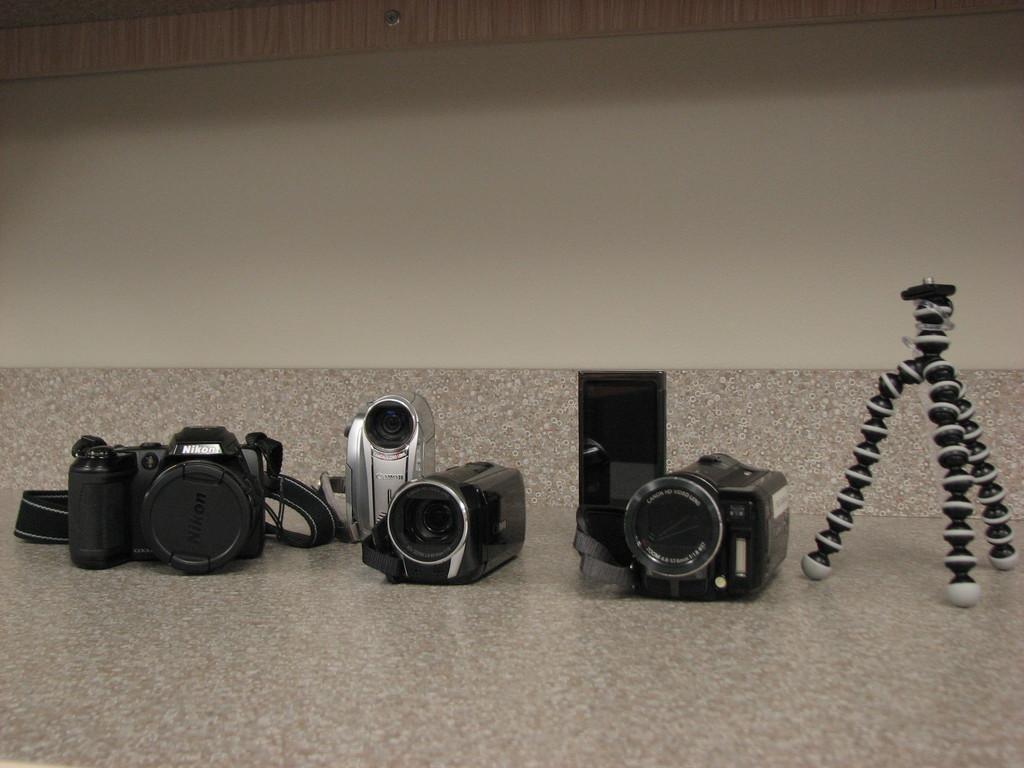Can you describe this image briefly? In this image, I can see many cameras and a stand on the surface, and background is the wall. 